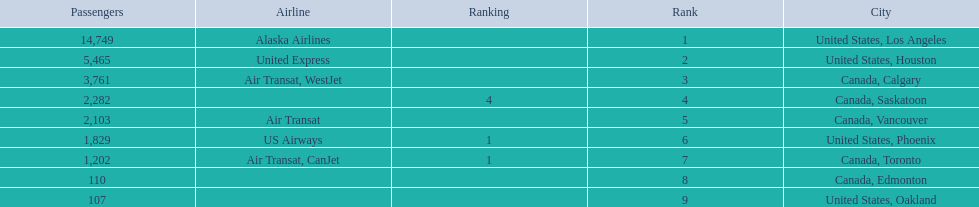What is the average number of passengers in the united states? 5537.5. 